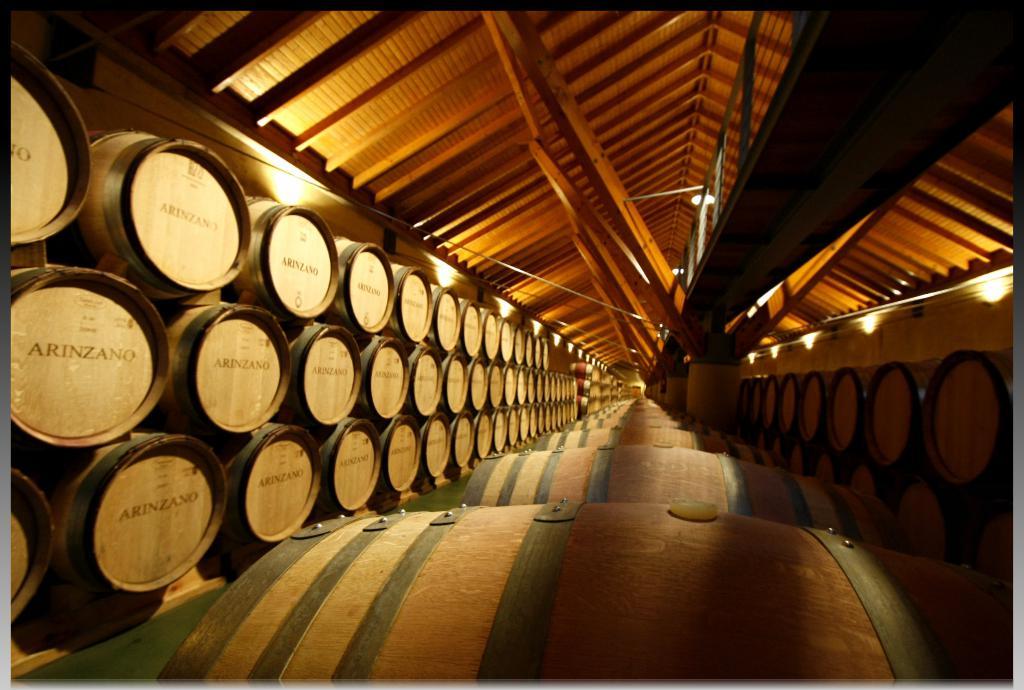What is written on the end of these barrels?
Make the answer very short. Arinzano. 